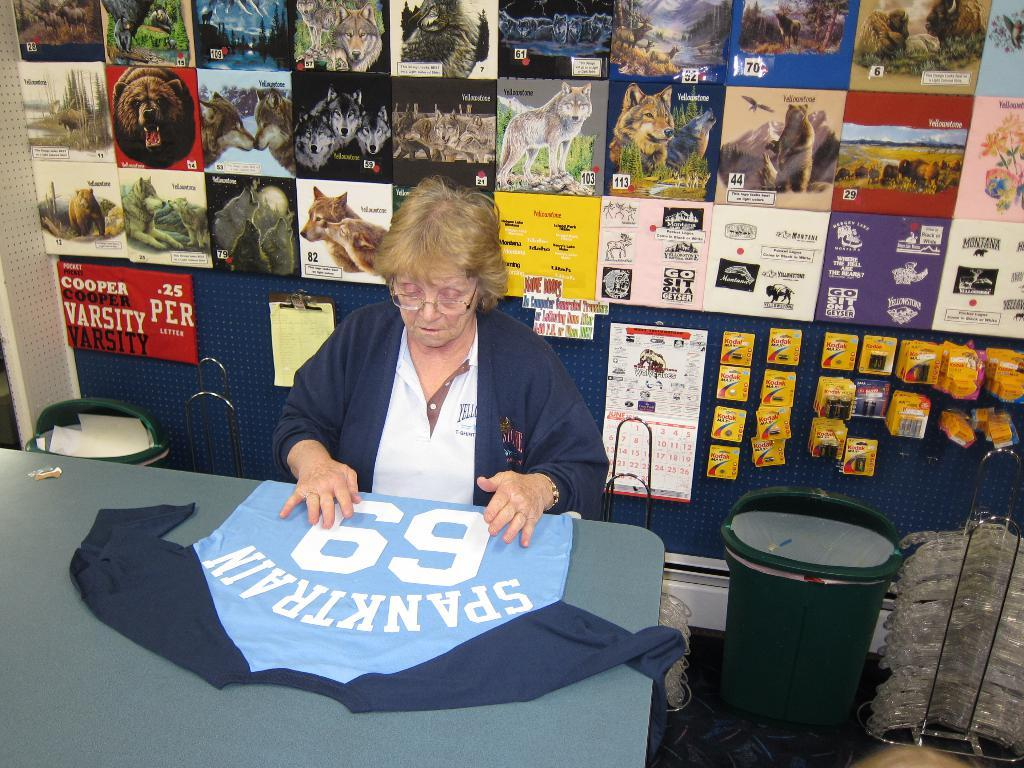<image>
Create a compact narrative representing the image presented. Woman sitting at a table with a jersey saying number 69. 